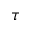Convert formula to latex. <formula><loc_0><loc_0><loc_500><loc_500>\tau</formula> 